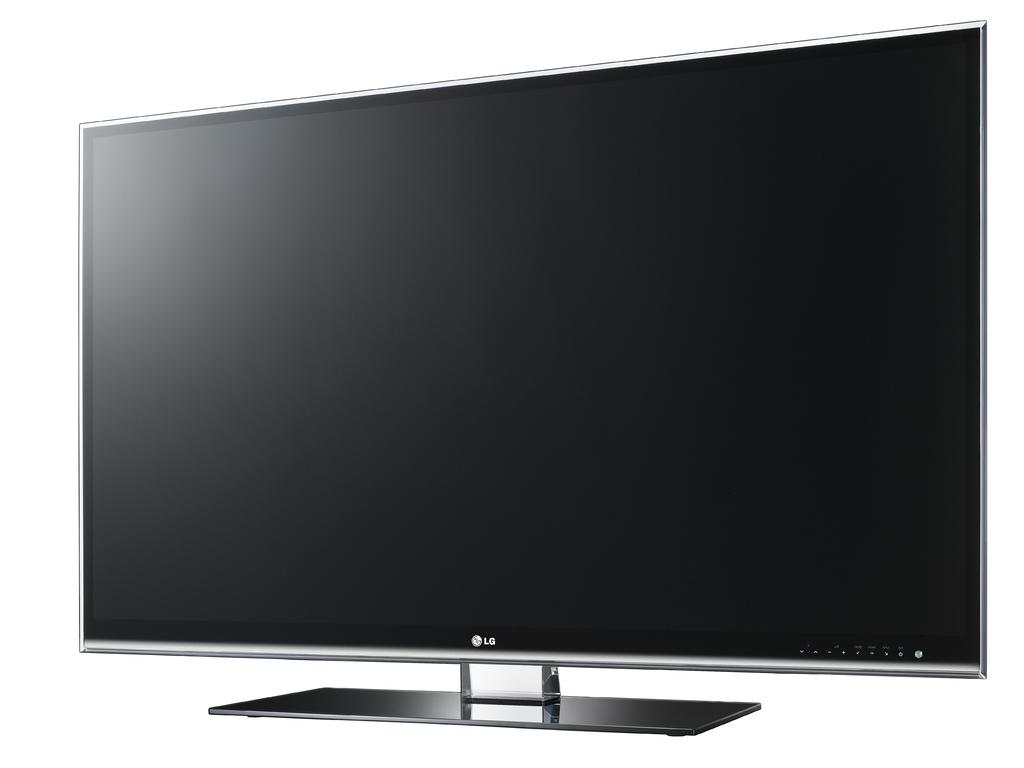<image>
Describe the image concisely. A stock image of an LG television monitor. 